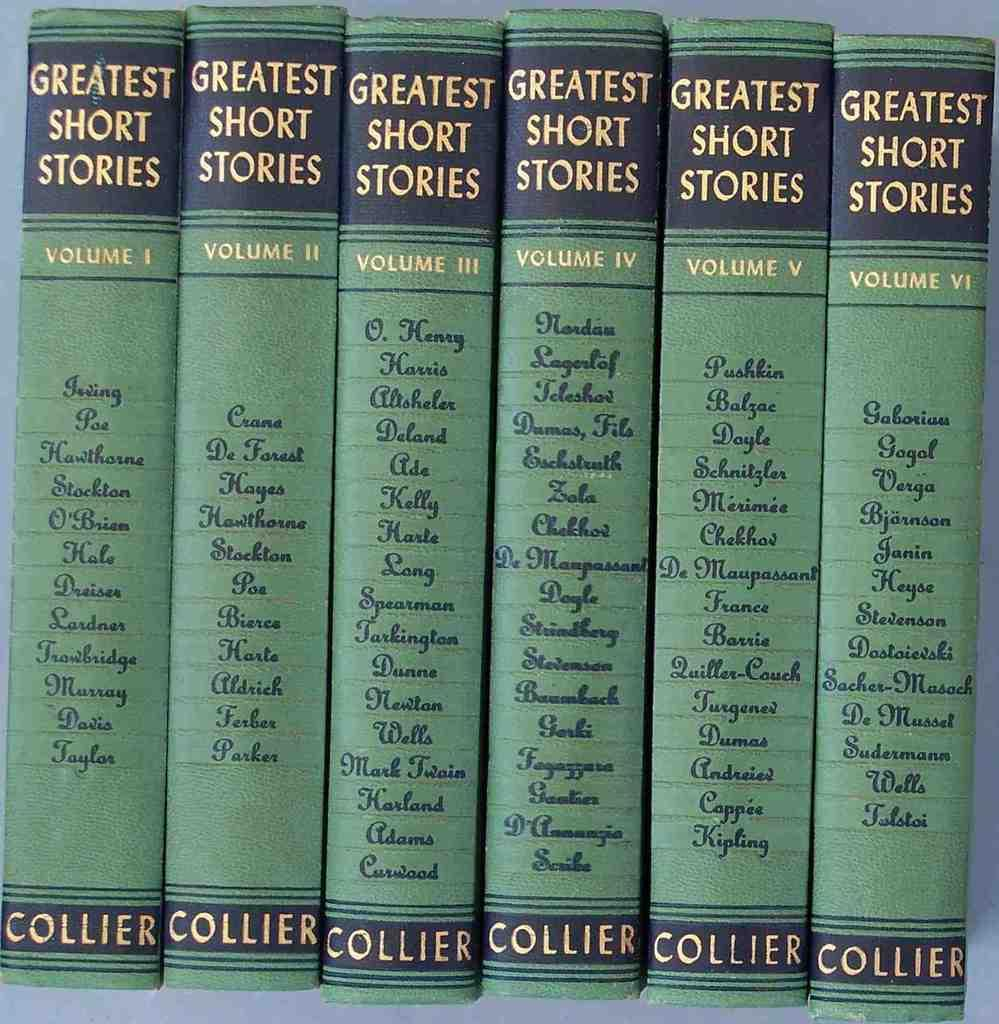<image>
Create a compact narrative representing the image presented. Many volumes of a book titled Greatest Short Stories. 